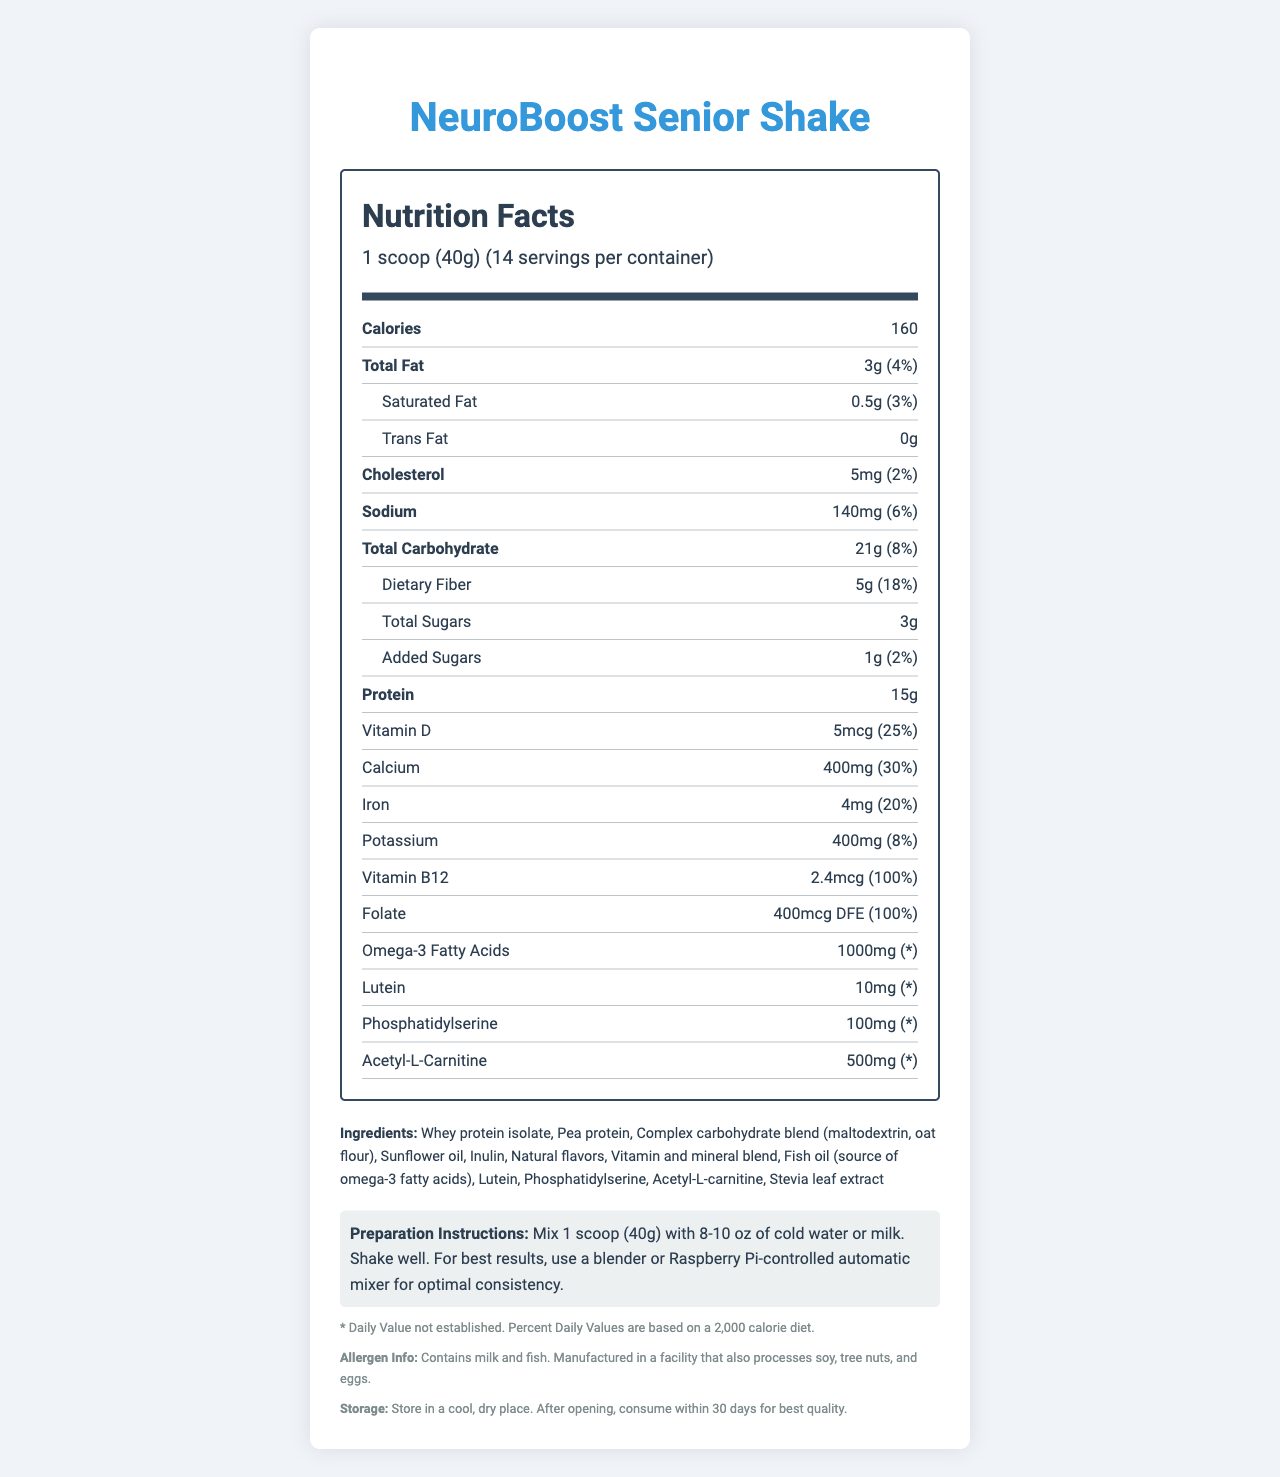what is the product name? The product name "NeuroBoost Senior Shake" is clearly stated at the beginning of the document.
Answer: NeuroBoost Senior Shake how many calories are in one serving? The calories content in one serving is listed as 160.
Answer: 160 what is the amount of protein per serving? The amount of protein per serving is stated to be 15g.
Answer: 15g how much dietary fiber is there per serving? The dietary fiber per serving is listed as 5g.
Answer: 5g what are the preparation instructions for the shake? The preparation instructions are stated at the end of the document in a separate "instructions" section.
Answer: Mix 1 scoop (40g) with 8-10 oz of cold water or milk. Shake well. For best results, use a blender or Raspberry Pi-controlled automatic mixer for optimal consistency. what is the daily value percentage of Vitamin B12 in this product? The daily value percentage for Vitamin B12 is listed as 100%.
Answer: 100% what allergens are present in this product? The allergen information states the product contains milk and fish and was manufactured in a facility that also processes soy, tree nuts, and eggs.
Answer: Contains milk and fish. Manufactured in a facility that also processes soy, tree nuts, and eggs. how much vitamin D is in one serving? The vitamin D content per serving is 5mcg.
Answer: 5mcg how much sodium is there per serving? A. 120mg B. 140mg C. 150mg D. 160mg The amount of sodium per serving is listed as 140mg.
Answer: B. 140mg what is the daily value percentage of calcium in this product? A. 20% B. 25% C. 30% D. 35% The daily value percentage of calcium is listed as 30%.
Answer: C. 30% is this product gluten-free? The document does not specify whether the product is gluten-free.
Answer: Not enough information does this shake contain any added sugars? The document states the shake contains 1g of added sugars.
Answer: Yes summarize the main idea of the document. The document provides comprehensive details about the product's nutritional content, special ingredients, allergen information, and usage instructions, highlighting its suitability for seniors seeking to boost their brain health through nutrition.
Answer: The document outlines the nutritional information of "NeuroBoost Senior Shake," a meal replacement optimized for brain health and cognitive function. It provides details about serving size, calories, macronutrients, vitamins, and special ingredients aimed at supporting brain health. The document also includes information on allergens, storage, and preparation instructions. 